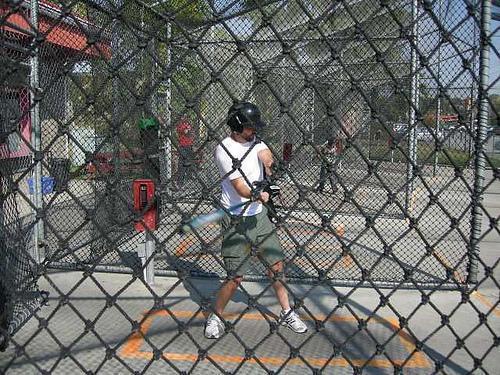What is the man standing in?
Answer the question by selecting the correct answer among the 4 following choices.
Options: School yard, batting cage, prison cell, backyard. Batting cage. 